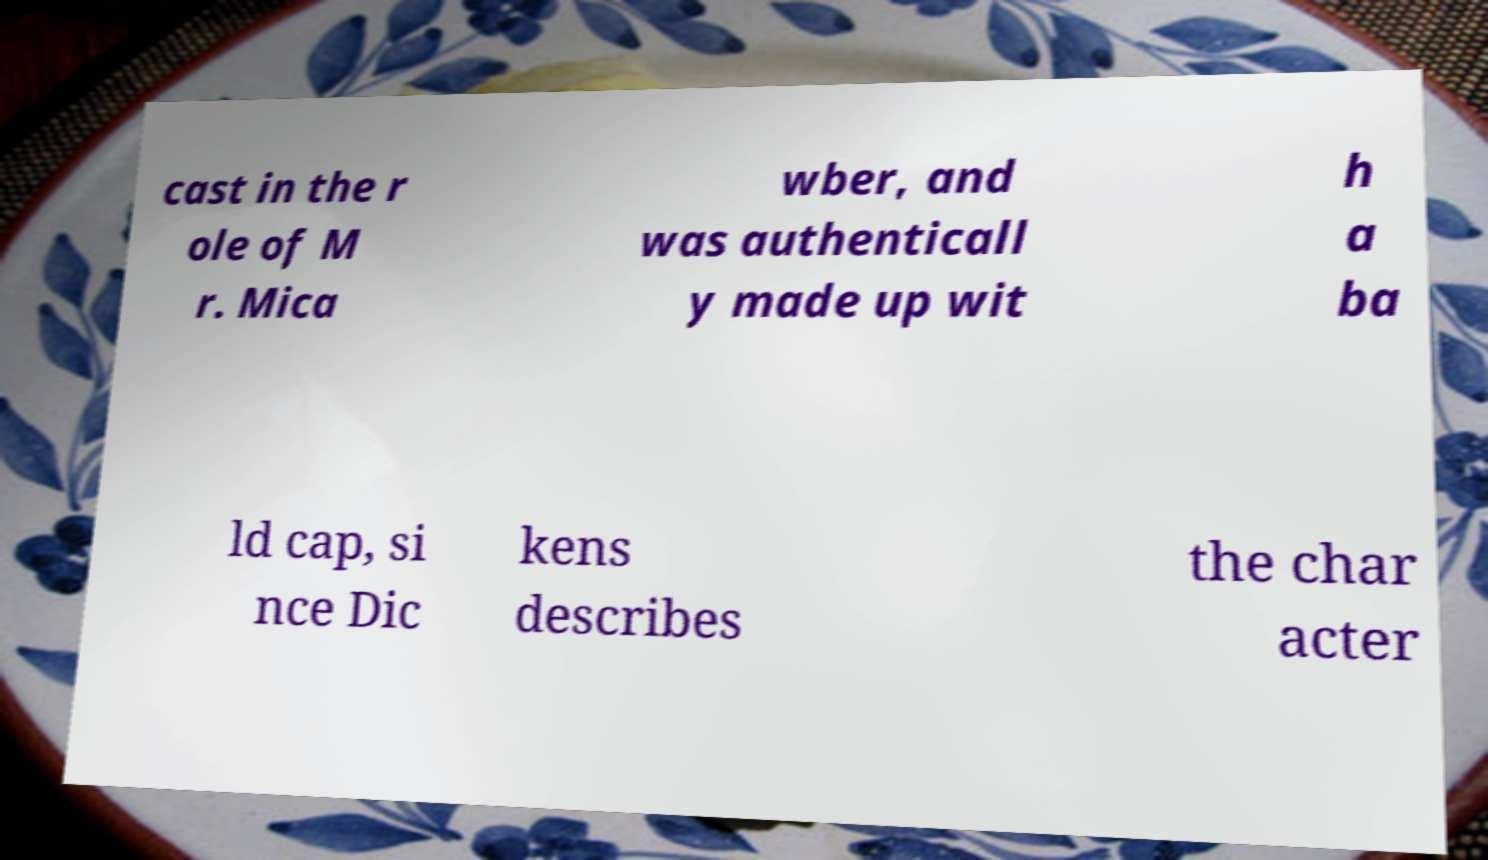Can you accurately transcribe the text from the provided image for me? cast in the r ole of M r. Mica wber, and was authenticall y made up wit h a ba ld cap, si nce Dic kens describes the char acter 